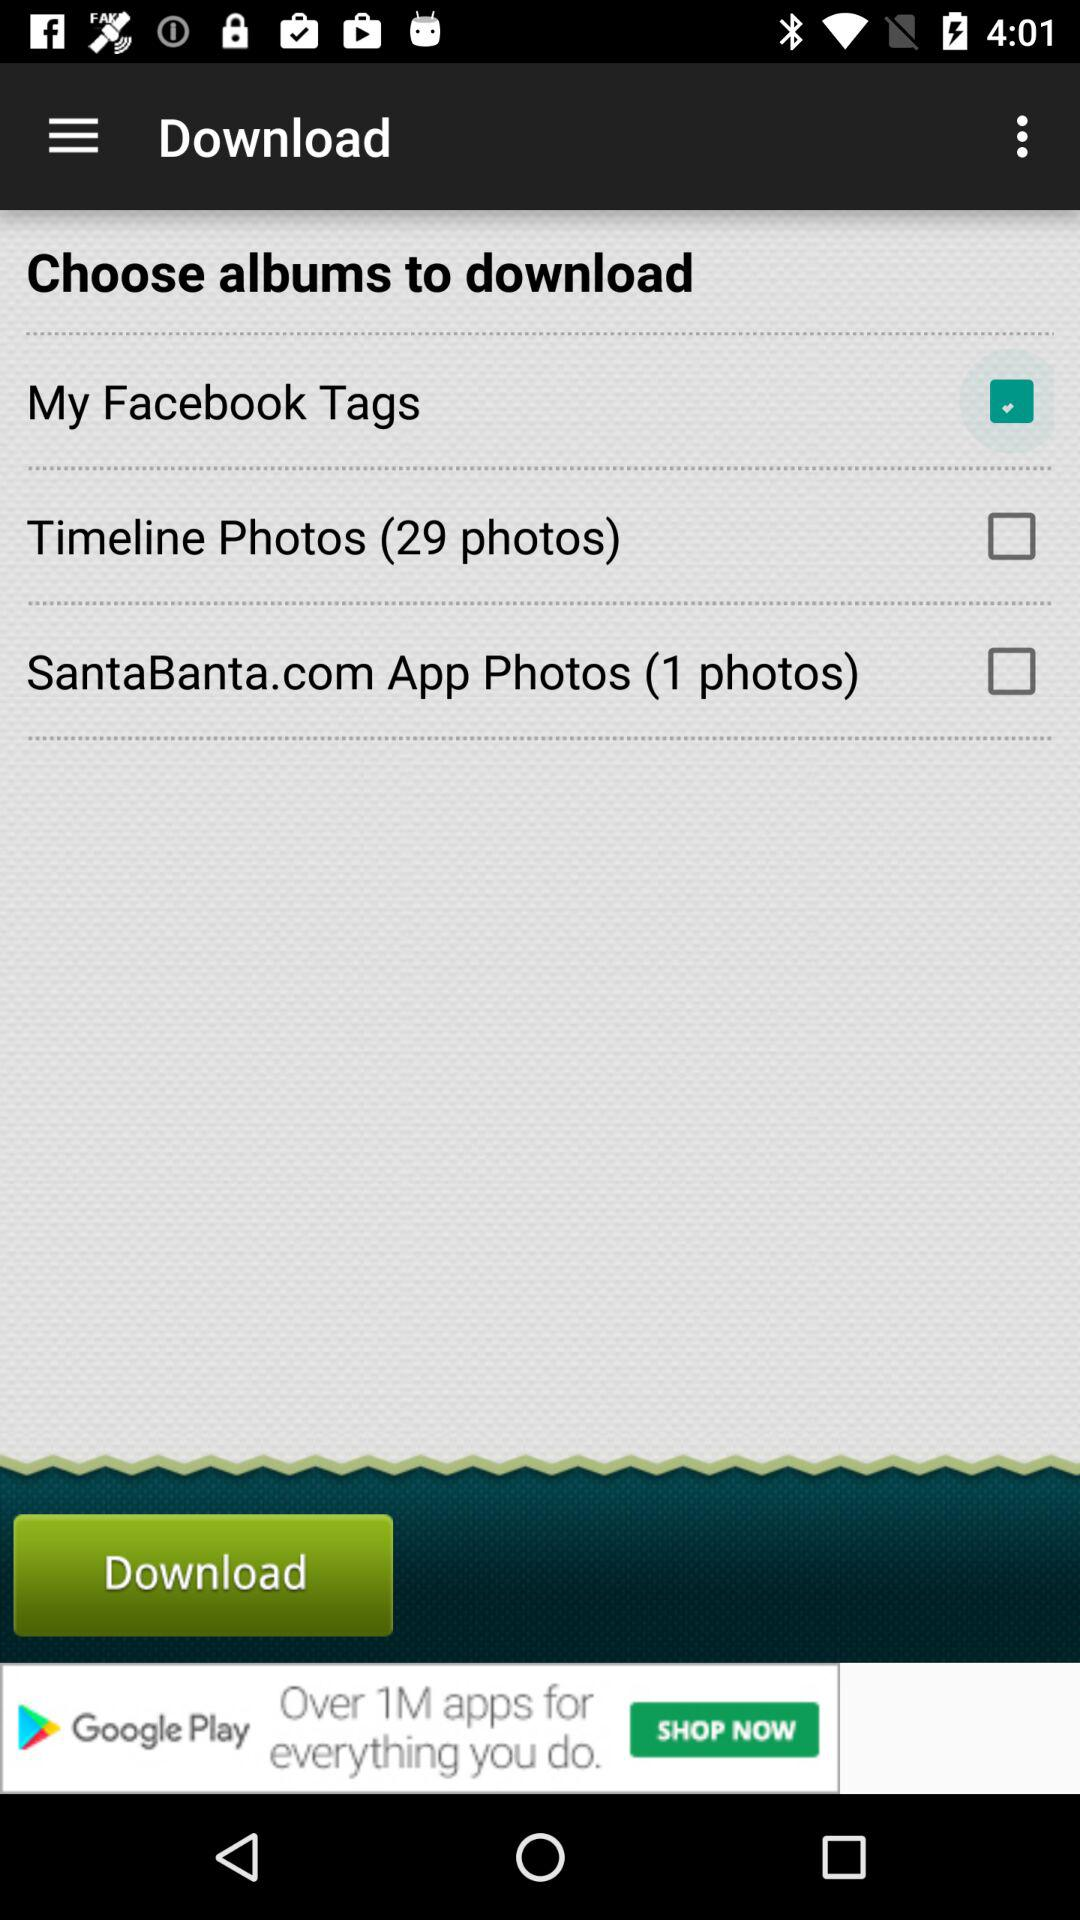What are the albums that you can choose to download? The albums that you can choose to download are "My Facebook Tags", "Timeline Photos (29 photos)" and "SantaBanta.com App Photos (1 photos)". 